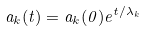<formula> <loc_0><loc_0><loc_500><loc_500>a _ { k } ( t ) = a _ { k } ( 0 ) e ^ { t / \lambda _ { k } }</formula> 